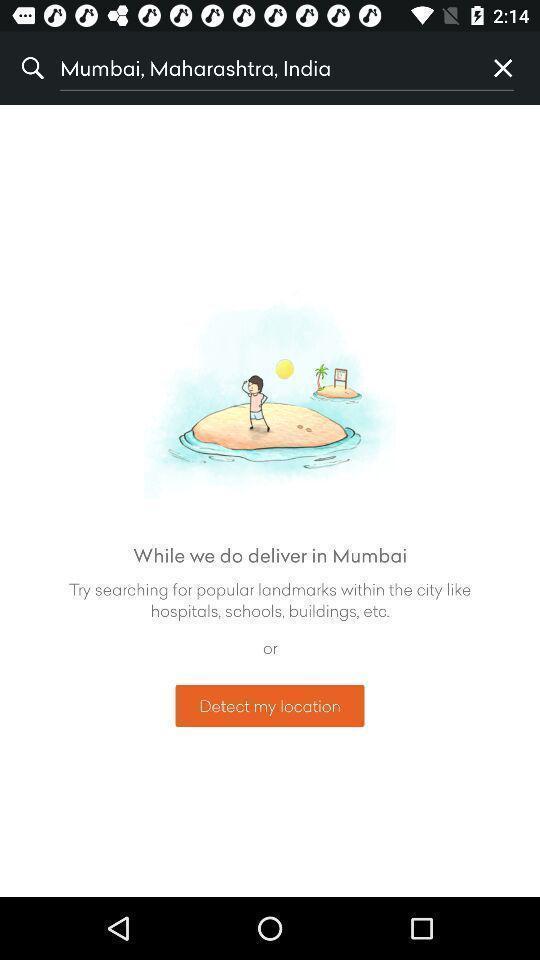What details can you identify in this image? Screen shows search option in a navigation app. 